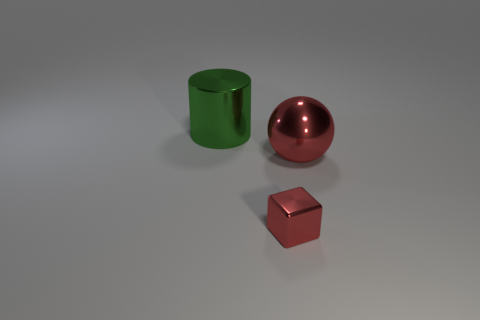How many shiny cubes are the same size as the red metal ball?
Your answer should be compact. 0. Are there the same number of shiny objects that are behind the green shiny cylinder and green things that are in front of the red shiny ball?
Your response must be concise. Yes. Do the large cylinder and the small red thing have the same material?
Your response must be concise. Yes. There is a big metallic thing that is in front of the large metal cylinder; is there a green shiny object that is in front of it?
Provide a succinct answer. No. Is there a small cyan thing of the same shape as the small red shiny thing?
Offer a terse response. No. Does the large metal sphere have the same color as the metal cylinder?
Your answer should be compact. No. What material is the large object that is to the right of the object in front of the big red metallic ball made of?
Keep it short and to the point. Metal. How big is the metallic cube?
Keep it short and to the point. Small. The cylinder that is the same material as the sphere is what size?
Make the answer very short. Large. There is a metallic object behind the red shiny ball; does it have the same size as the tiny metal thing?
Offer a terse response. No. 